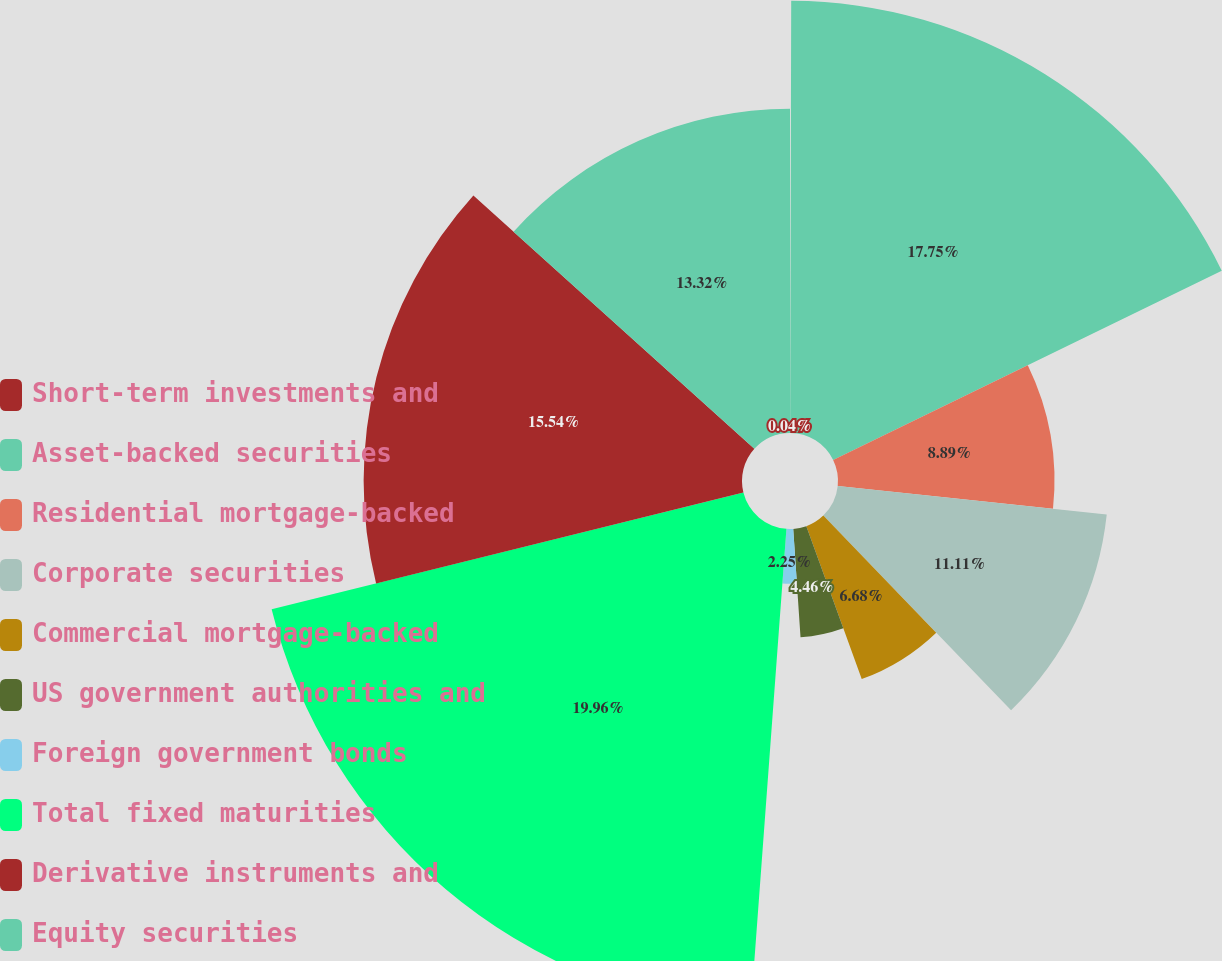<chart> <loc_0><loc_0><loc_500><loc_500><pie_chart><fcel>Short-term investments and<fcel>Asset-backed securities<fcel>Residential mortgage-backed<fcel>Corporate securities<fcel>Commercial mortgage-backed<fcel>US government authorities and<fcel>Foreign government bonds<fcel>Total fixed maturities<fcel>Derivative instruments and<fcel>Equity securities<nl><fcel>0.04%<fcel>17.75%<fcel>8.89%<fcel>11.11%<fcel>6.68%<fcel>4.46%<fcel>2.25%<fcel>19.96%<fcel>15.54%<fcel>13.32%<nl></chart> 